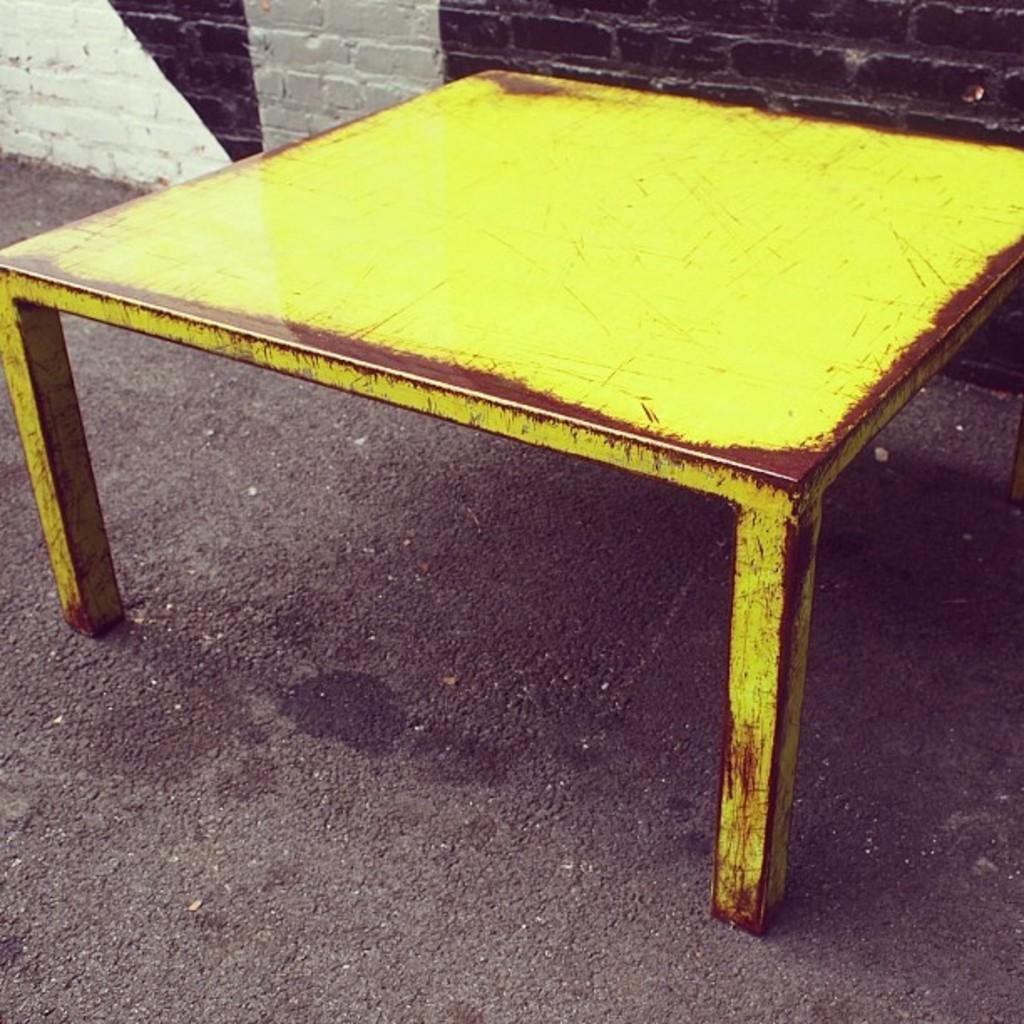Could you give a brief overview of what you see in this image? In this image I see the yellow and brown color thing on this ground and I see the wall in the background. 